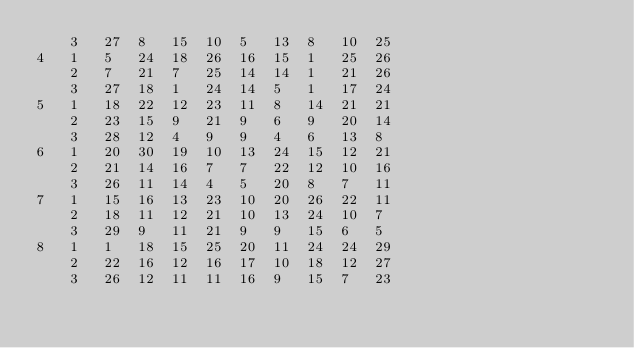<code> <loc_0><loc_0><loc_500><loc_500><_ObjectiveC_>	3	27	8	15	10	5	13	8	10	25	
4	1	5	24	18	26	16	15	1	25	26	
	2	7	21	7	25	14	14	1	21	26	
	3	27	18	1	24	14	5	1	17	24	
5	1	18	22	12	23	11	8	14	21	21	
	2	23	15	9	21	9	6	9	20	14	
	3	28	12	4	9	9	4	6	13	8	
6	1	20	30	19	10	13	24	15	12	21	
	2	21	14	16	7	7	22	12	10	16	
	3	26	11	14	4	5	20	8	7	11	
7	1	15	16	13	23	10	20	26	22	11	
	2	18	11	12	21	10	13	24	10	7	
	3	29	9	11	21	9	9	15	6	5	
8	1	1	18	15	25	20	11	24	24	29	
	2	22	16	12	16	17	10	18	12	27	
	3	26	12	11	11	16	9	15	7	23	</code> 